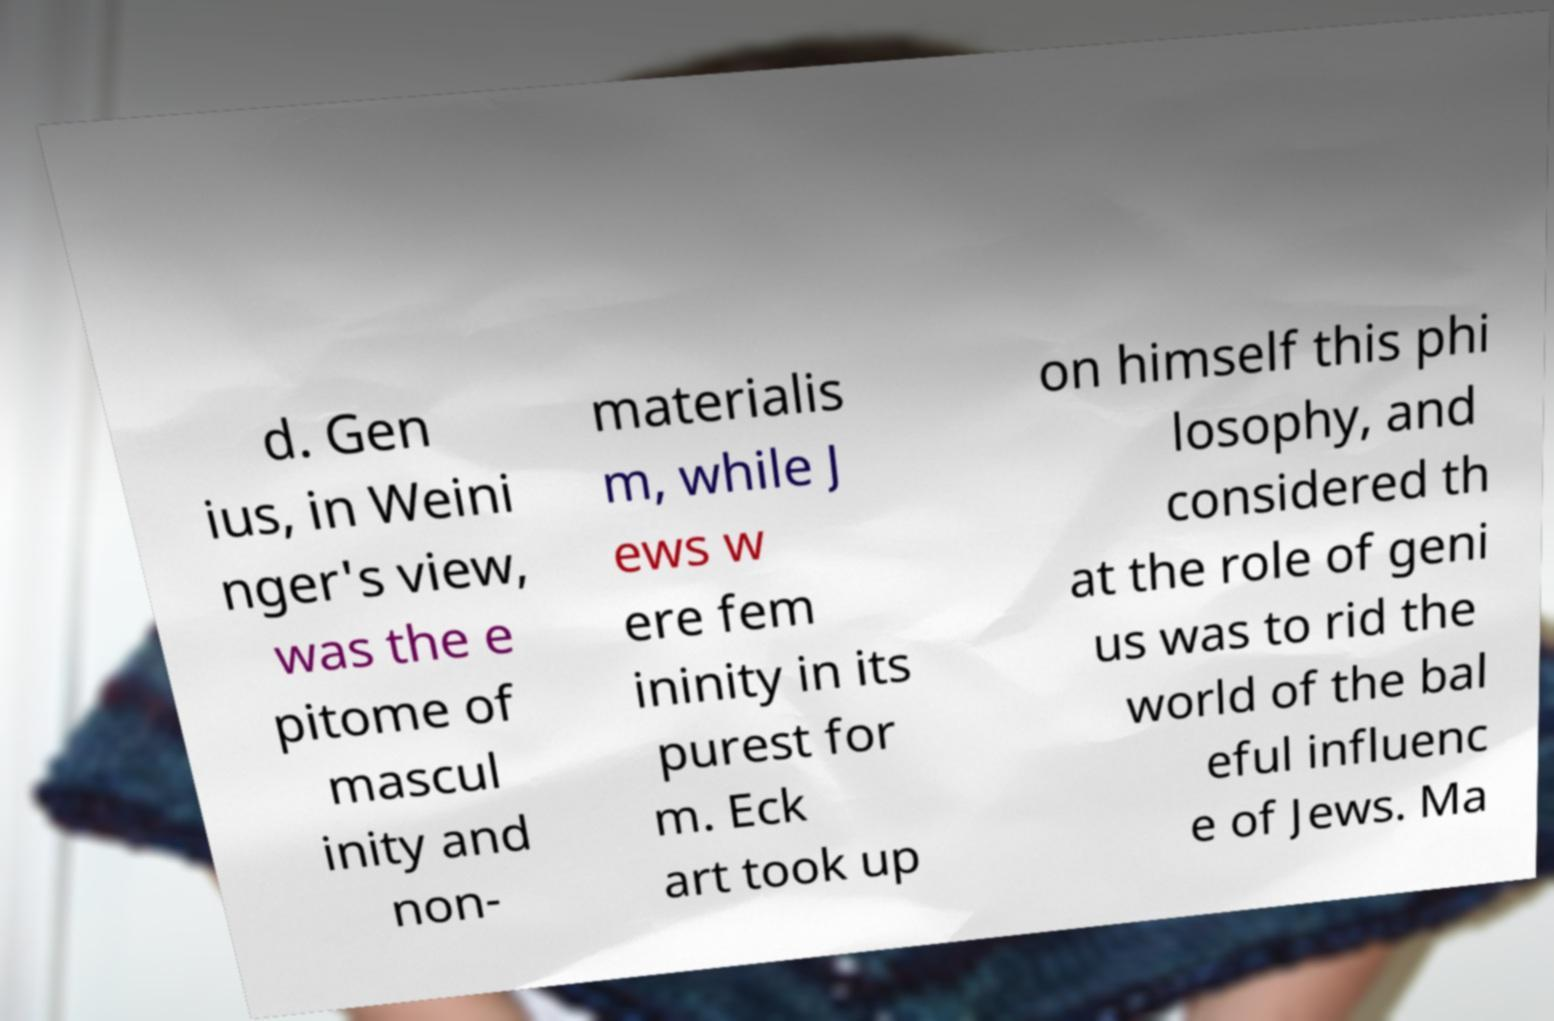Could you extract and type out the text from this image? d. Gen ius, in Weini nger's view, was the e pitome of mascul inity and non- materialis m, while J ews w ere fem ininity in its purest for m. Eck art took up on himself this phi losophy, and considered th at the role of geni us was to rid the world of the bal eful influenc e of Jews. Ma 